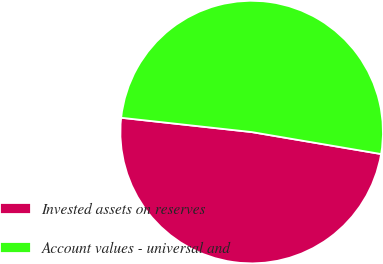Convert chart. <chart><loc_0><loc_0><loc_500><loc_500><pie_chart><fcel>Invested assets on reserves<fcel>Account values - universal and<nl><fcel>49.06%<fcel>50.94%<nl></chart> 